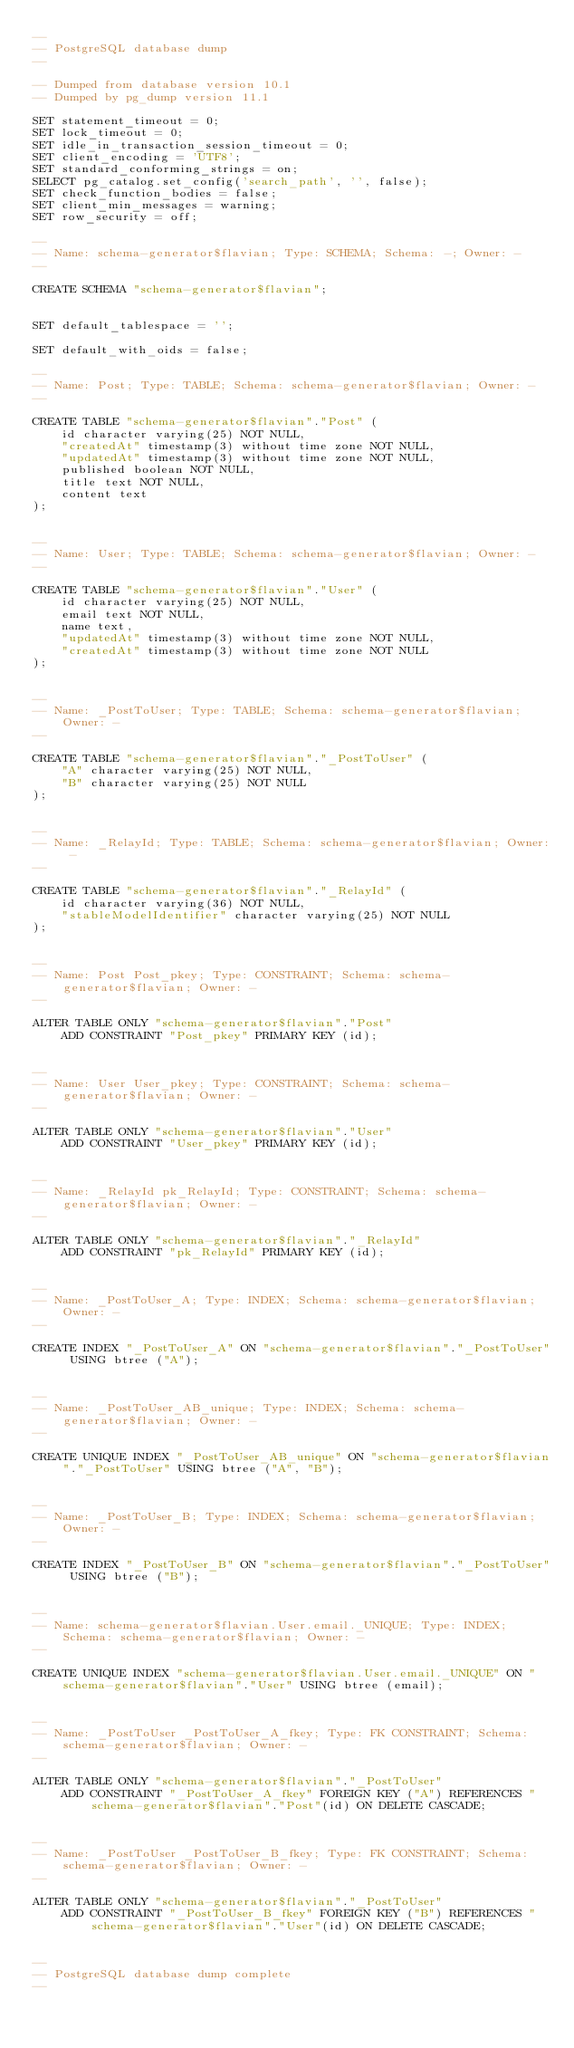<code> <loc_0><loc_0><loc_500><loc_500><_SQL_>--
-- PostgreSQL database dump
--

-- Dumped from database version 10.1
-- Dumped by pg_dump version 11.1

SET statement_timeout = 0;
SET lock_timeout = 0;
SET idle_in_transaction_session_timeout = 0;
SET client_encoding = 'UTF8';
SET standard_conforming_strings = on;
SELECT pg_catalog.set_config('search_path', '', false);
SET check_function_bodies = false;
SET client_min_messages = warning;
SET row_security = off;

--
-- Name: schema-generator$flavian; Type: SCHEMA; Schema: -; Owner: -
--

CREATE SCHEMA "schema-generator$flavian";


SET default_tablespace = '';

SET default_with_oids = false;

--
-- Name: Post; Type: TABLE; Schema: schema-generator$flavian; Owner: -
--

CREATE TABLE "schema-generator$flavian"."Post" (
    id character varying(25) NOT NULL,
    "createdAt" timestamp(3) without time zone NOT NULL,
    "updatedAt" timestamp(3) without time zone NOT NULL,
    published boolean NOT NULL,
    title text NOT NULL,
    content text
);


--
-- Name: User; Type: TABLE; Schema: schema-generator$flavian; Owner: -
--

CREATE TABLE "schema-generator$flavian"."User" (
    id character varying(25) NOT NULL,
    email text NOT NULL,
    name text,
    "updatedAt" timestamp(3) without time zone NOT NULL,
    "createdAt" timestamp(3) without time zone NOT NULL
);


--
-- Name: _PostToUser; Type: TABLE; Schema: schema-generator$flavian; Owner: -
--

CREATE TABLE "schema-generator$flavian"."_PostToUser" (
    "A" character varying(25) NOT NULL,
    "B" character varying(25) NOT NULL
);


--
-- Name: _RelayId; Type: TABLE; Schema: schema-generator$flavian; Owner: -
--

CREATE TABLE "schema-generator$flavian"."_RelayId" (
    id character varying(36) NOT NULL,
    "stableModelIdentifier" character varying(25) NOT NULL
);


--
-- Name: Post Post_pkey; Type: CONSTRAINT; Schema: schema-generator$flavian; Owner: -
--

ALTER TABLE ONLY "schema-generator$flavian"."Post"
    ADD CONSTRAINT "Post_pkey" PRIMARY KEY (id);


--
-- Name: User User_pkey; Type: CONSTRAINT; Schema: schema-generator$flavian; Owner: -
--

ALTER TABLE ONLY "schema-generator$flavian"."User"
    ADD CONSTRAINT "User_pkey" PRIMARY KEY (id);


--
-- Name: _RelayId pk_RelayId; Type: CONSTRAINT; Schema: schema-generator$flavian; Owner: -
--

ALTER TABLE ONLY "schema-generator$flavian"."_RelayId"
    ADD CONSTRAINT "pk_RelayId" PRIMARY KEY (id);


--
-- Name: _PostToUser_A; Type: INDEX; Schema: schema-generator$flavian; Owner: -
--

CREATE INDEX "_PostToUser_A" ON "schema-generator$flavian"."_PostToUser" USING btree ("A");


--
-- Name: _PostToUser_AB_unique; Type: INDEX; Schema: schema-generator$flavian; Owner: -
--

CREATE UNIQUE INDEX "_PostToUser_AB_unique" ON "schema-generator$flavian"."_PostToUser" USING btree ("A", "B");


--
-- Name: _PostToUser_B; Type: INDEX; Schema: schema-generator$flavian; Owner: -
--

CREATE INDEX "_PostToUser_B" ON "schema-generator$flavian"."_PostToUser" USING btree ("B");


--
-- Name: schema-generator$flavian.User.email._UNIQUE; Type: INDEX; Schema: schema-generator$flavian; Owner: -
--

CREATE UNIQUE INDEX "schema-generator$flavian.User.email._UNIQUE" ON "schema-generator$flavian"."User" USING btree (email);


--
-- Name: _PostToUser _PostToUser_A_fkey; Type: FK CONSTRAINT; Schema: schema-generator$flavian; Owner: -
--

ALTER TABLE ONLY "schema-generator$flavian"."_PostToUser"
    ADD CONSTRAINT "_PostToUser_A_fkey" FOREIGN KEY ("A") REFERENCES "schema-generator$flavian"."Post"(id) ON DELETE CASCADE;


--
-- Name: _PostToUser _PostToUser_B_fkey; Type: FK CONSTRAINT; Schema: schema-generator$flavian; Owner: -
--

ALTER TABLE ONLY "schema-generator$flavian"."_PostToUser"
    ADD CONSTRAINT "_PostToUser_B_fkey" FOREIGN KEY ("B") REFERENCES "schema-generator$flavian"."User"(id) ON DELETE CASCADE;


--
-- PostgreSQL database dump complete
--

</code> 